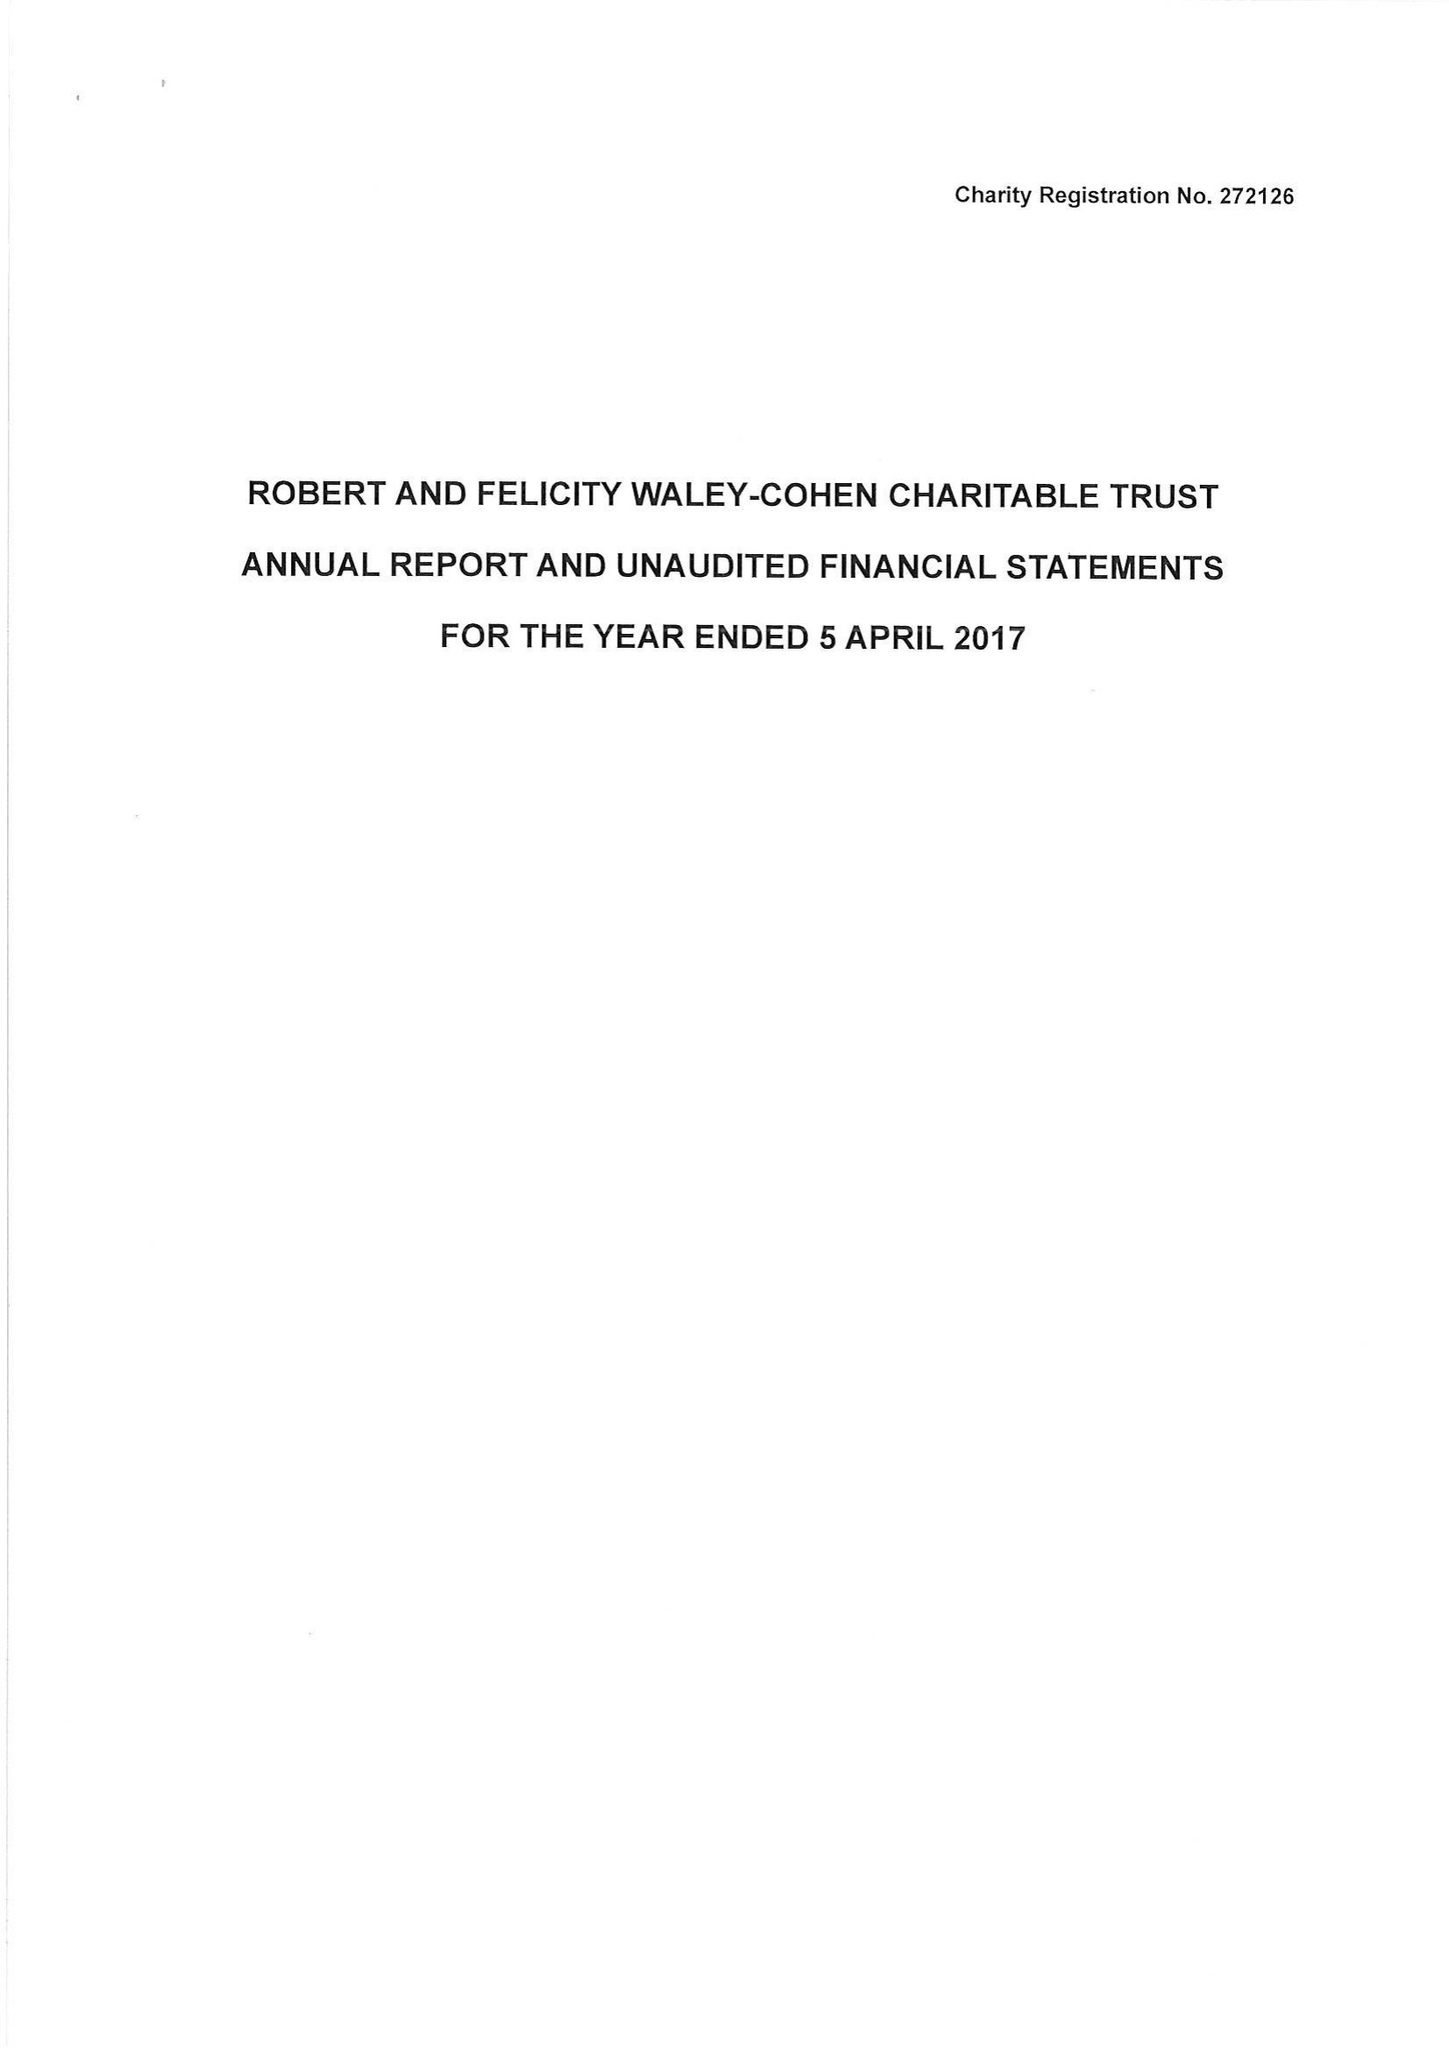What is the value for the income_annually_in_british_pounds?
Answer the question using a single word or phrase. 146383.00 